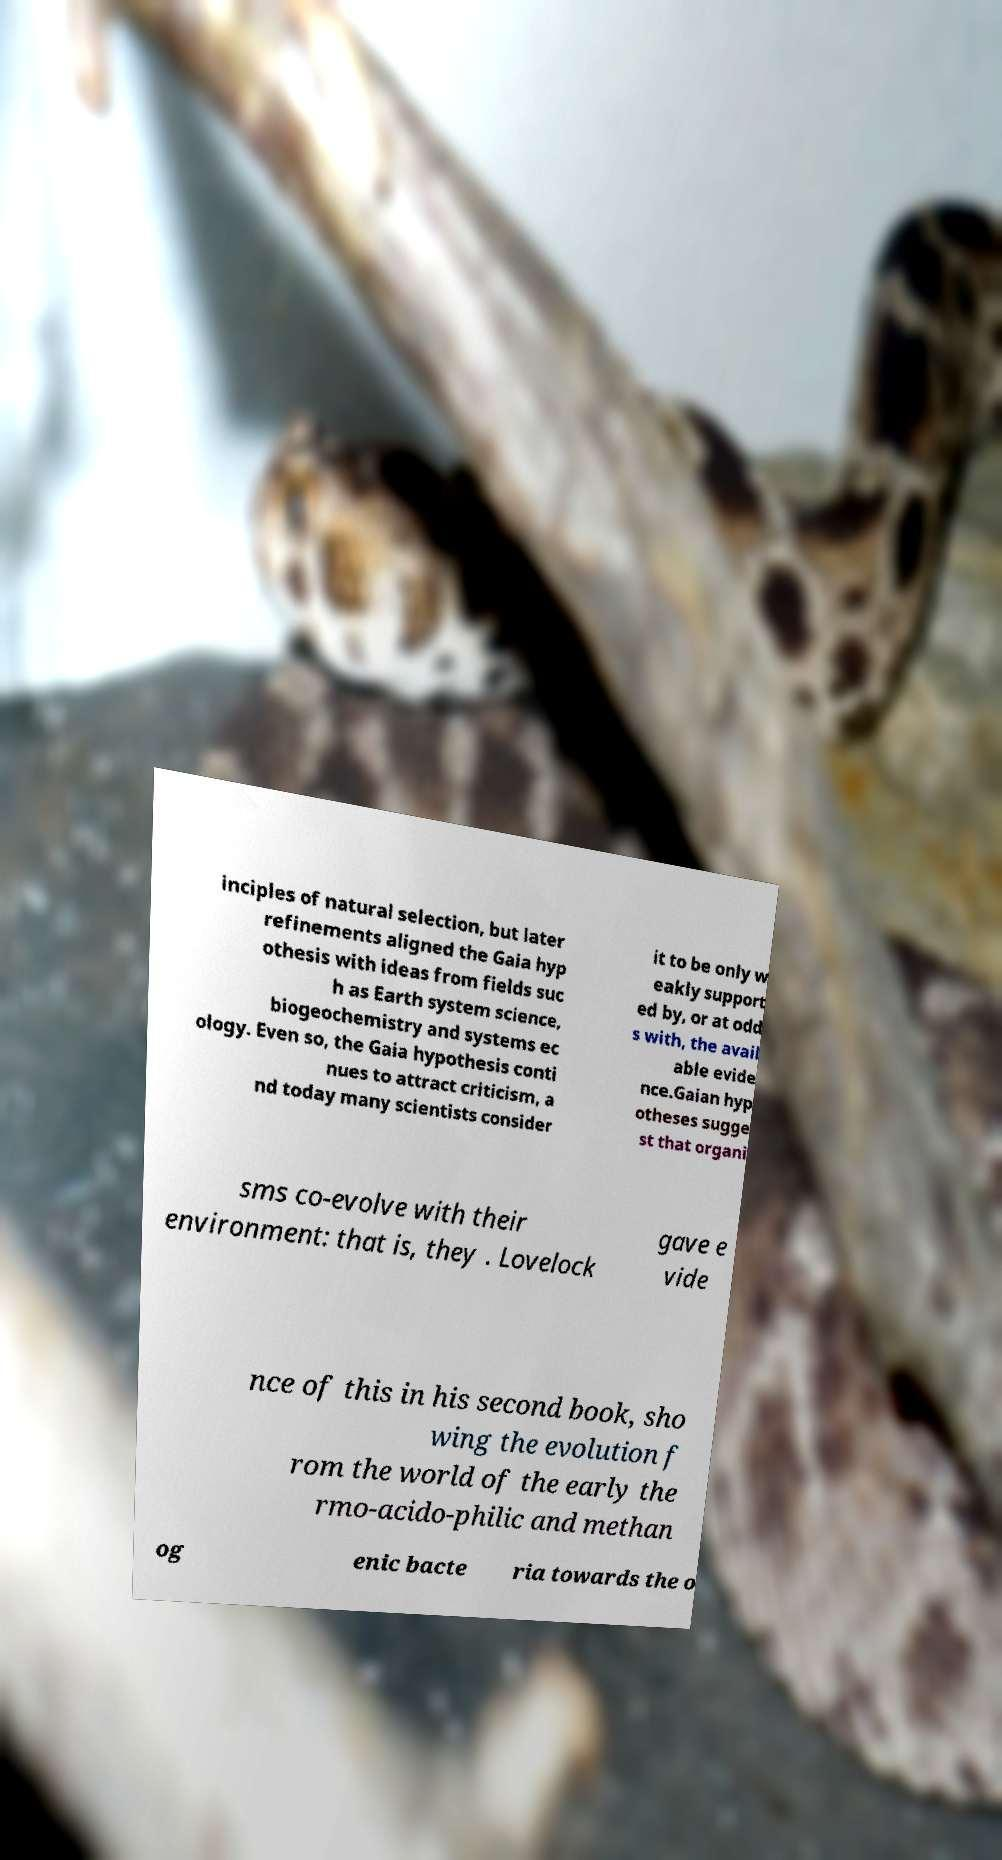Can you accurately transcribe the text from the provided image for me? inciples of natural selection, but later refinements aligned the Gaia hyp othesis with ideas from fields suc h as Earth system science, biogeochemistry and systems ec ology. Even so, the Gaia hypothesis conti nues to attract criticism, a nd today many scientists consider it to be only w eakly support ed by, or at odd s with, the avail able evide nce.Gaian hyp otheses sugge st that organi sms co-evolve with their environment: that is, they . Lovelock gave e vide nce of this in his second book, sho wing the evolution f rom the world of the early the rmo-acido-philic and methan og enic bacte ria towards the o 